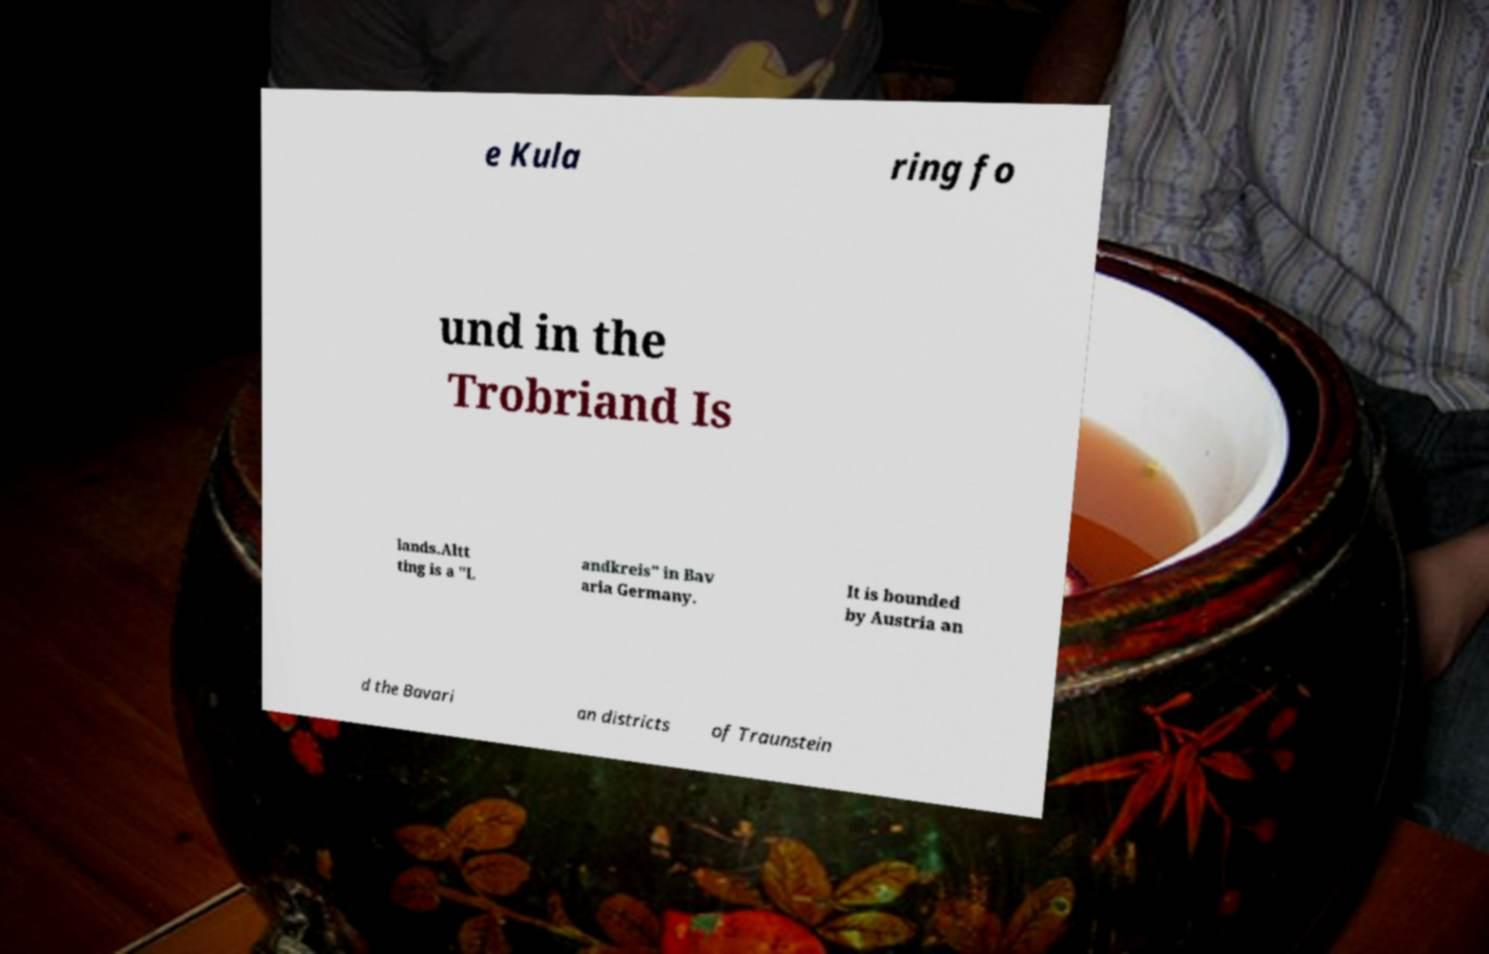I need the written content from this picture converted into text. Can you do that? e Kula ring fo und in the Trobriand Is lands.Altt ting is a "L andkreis" in Bav aria Germany. It is bounded by Austria an d the Bavari an districts of Traunstein 